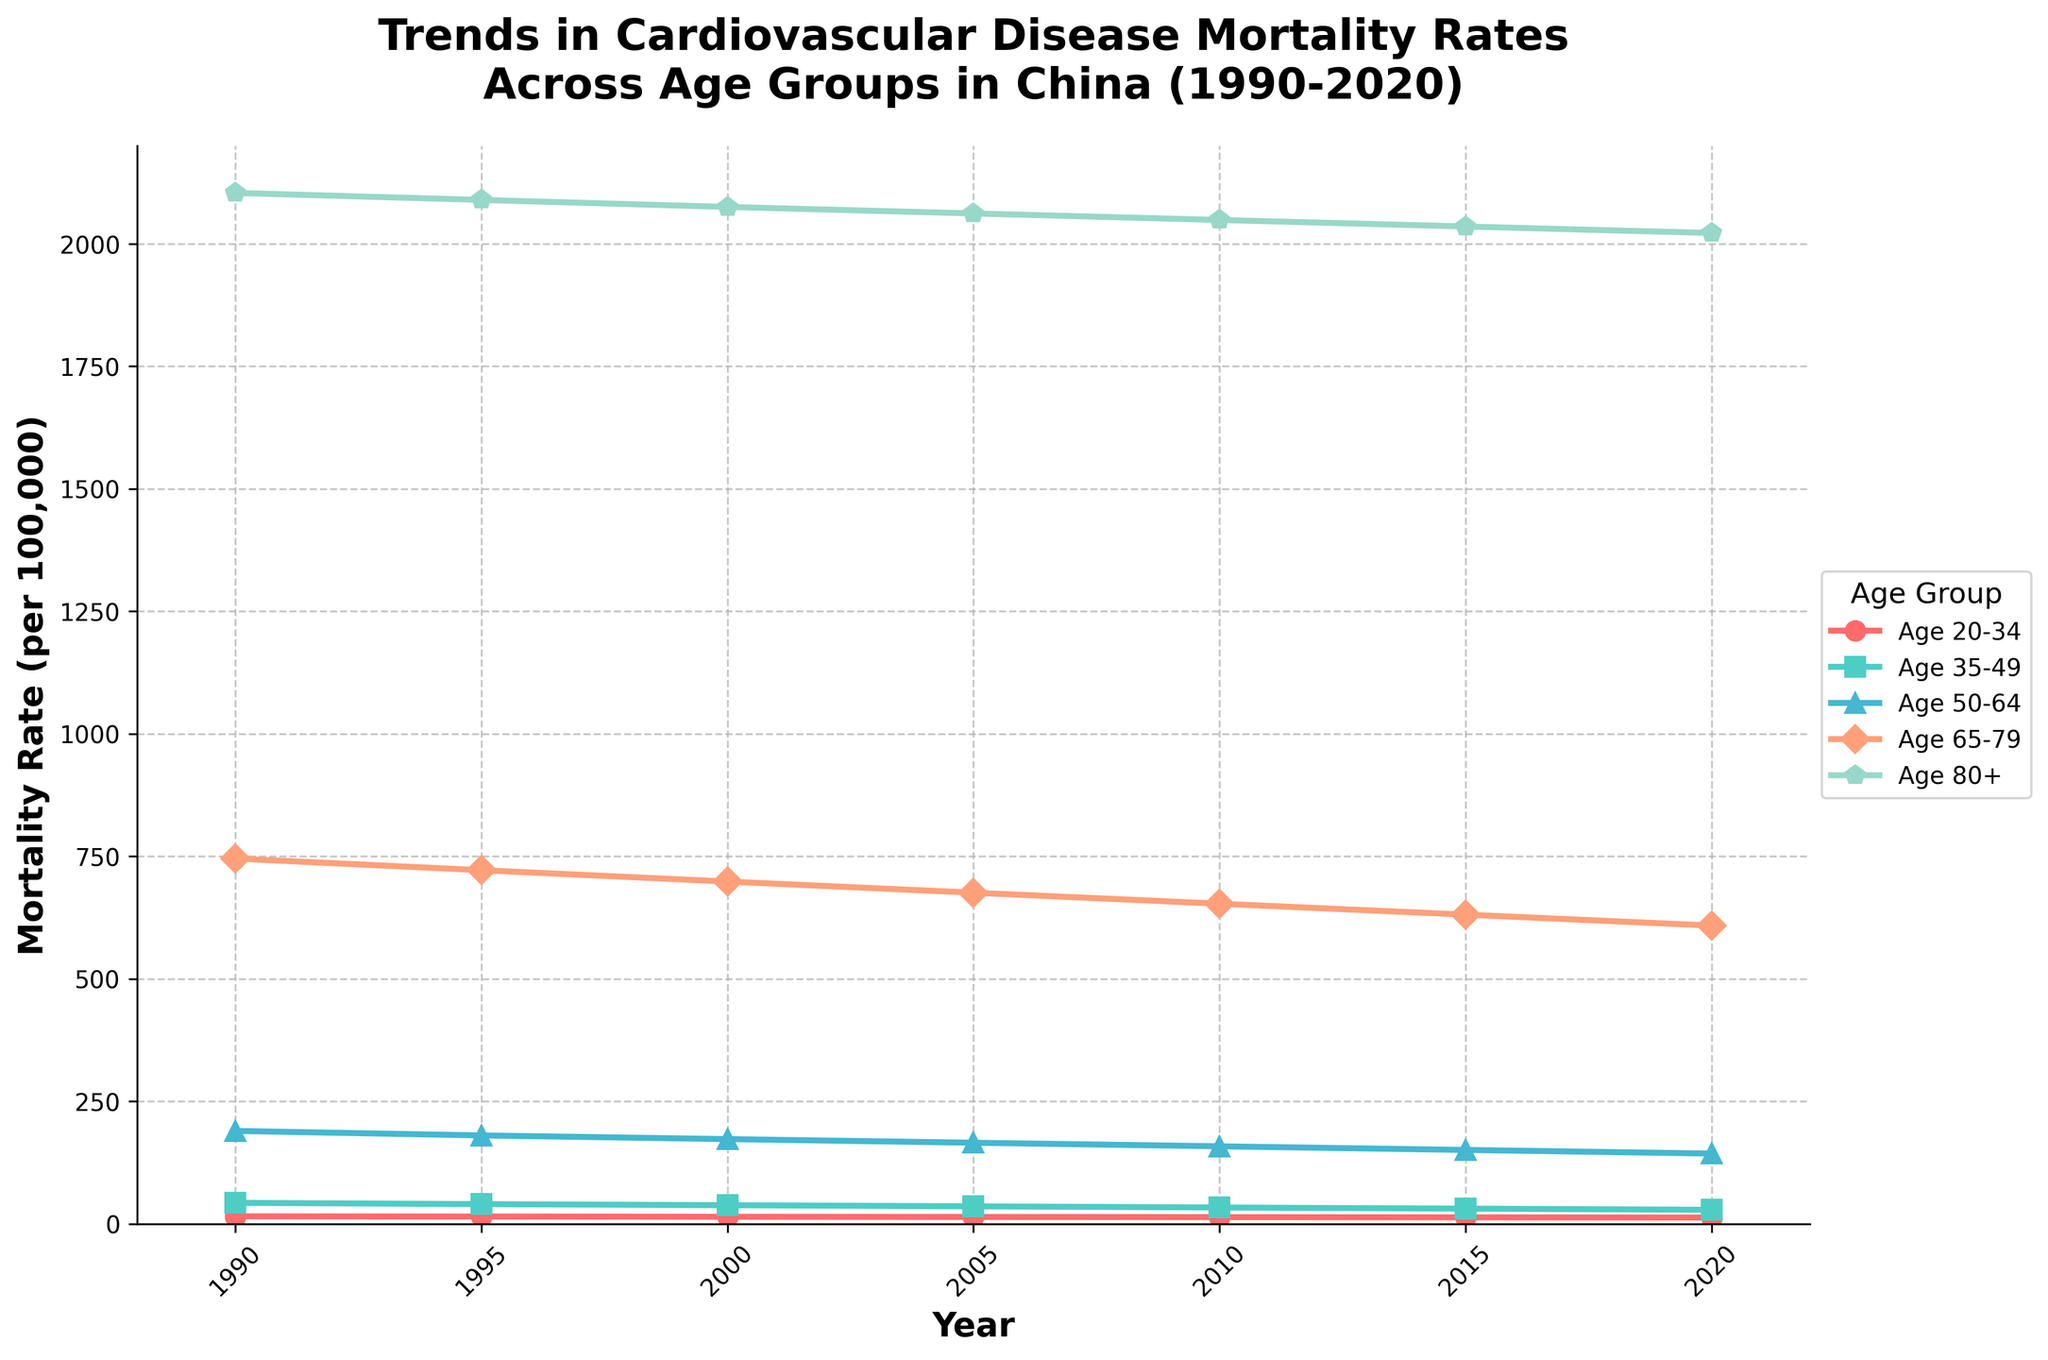What is the trend of cardiovascular disease mortality rates for the age group 65-79 from 1990 to 2020? The mortality rate in the age group 65-79 shows a consistent decline over the years. Observing the plot from 1990 to 2020, we see values decreasing from 745.3 to 608.6.
Answer: Consistent decline Which age group had the highest cardiovascular disease mortality rate in 2020? In 2020, the highest cardiovascular disease mortality rate is observed in the age group 80+. By comparing the end values of all lines, it's clear that the age group 80+ has the highest value at 2022.0.
Answer: Age 80+ Between the age groups 35-49 and 50-64, which one saw a greater decrease in cardiovascular disease mortality rates from 1990 to 2020? For age group 35-49, the rate dropped from 42.7 to 28.5, a decrease of 14.2. For age group 50-64, the rate dropped from 189.5 to 143.3, a decrease of 46.2. The age group 50-64 saw a greater decrease.
Answer: Age 50-64 What was the approximate average annual decrease in mortality rate for the age group 20-34 from 1990 to 2020? The mortality rate for the age group 20-34 decreased from 15.2 to 12.7 over 30 years. The total decrease is 15.2 - 12.7 = 2.5. Hence, the average annual decrease is 2.5 / 30 ≈ 0.083.
Answer: 0.083 Which age group has the steepest decline in the mortality rates over the years? By visually inspecting the slopes of the lines, the age group 50-64 appears to have the steepest downward trend. This can be inferred from the large change in mortality rates from 189.5 in 1990 to 143.3 in 2020.
Answer: Age 50-64 Estimate the difference in mortality rates between the age groups 35-49 and 80+ in 1990. In 1990, the mortality rates for age groups 35-49 and 80+ are 42.7 and 2103.8, respectively. The difference is 2103.8 - 42.7 = 2061.1.
Answer: 2061.1 Did the age group 65-79 ever have a mortality rate below 700? If yes, when did this happen? Yes, the age group 65-79 had mortality rates below 700 starting from the year 2000 onwards. This can be observed from the plot where the data points drop below 700 from 2000 to 2020.
Answer: 2000 onwards 